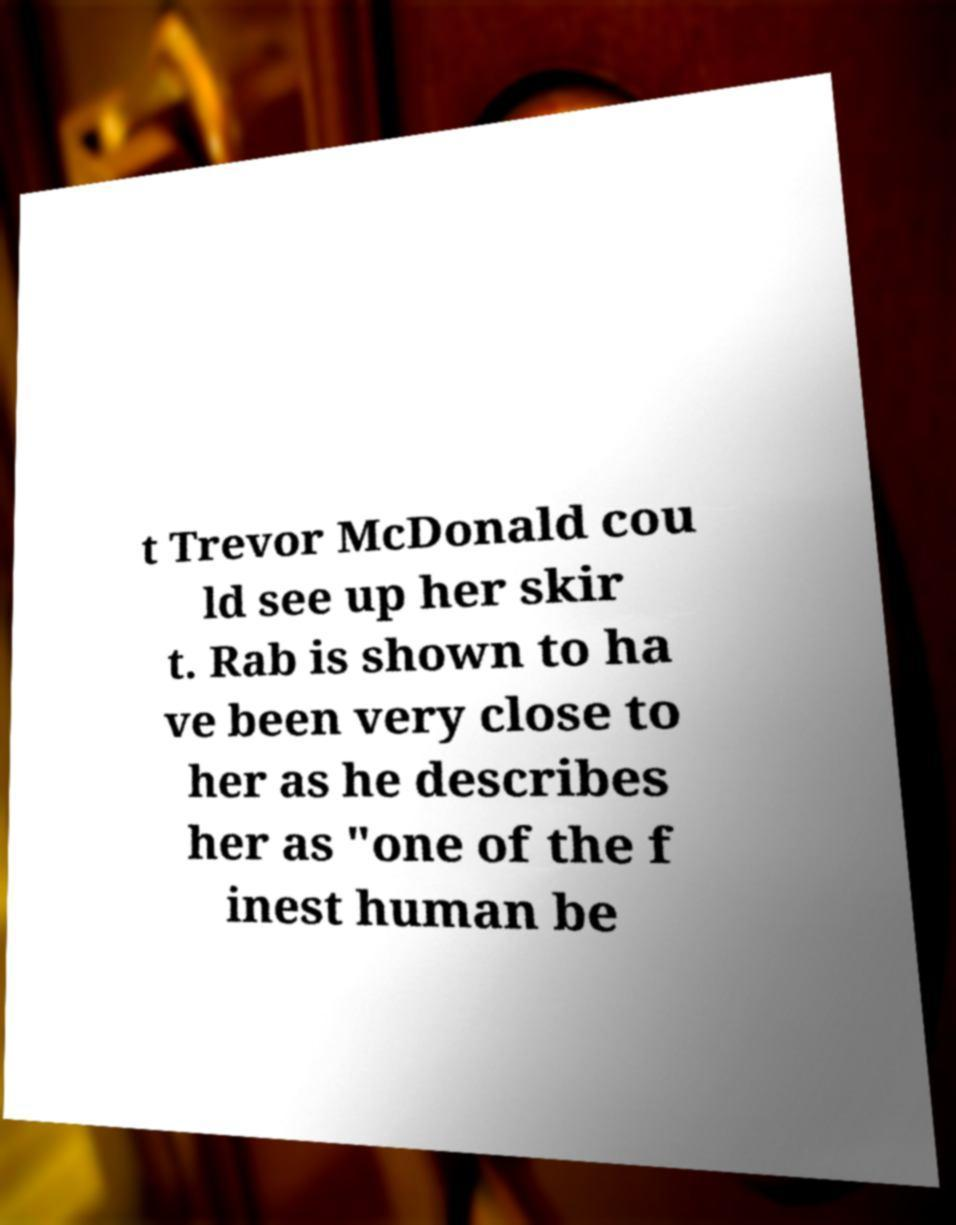Could you extract and type out the text from this image? t Trevor McDonald cou ld see up her skir t. Rab is shown to ha ve been very close to her as he describes her as "one of the f inest human be 